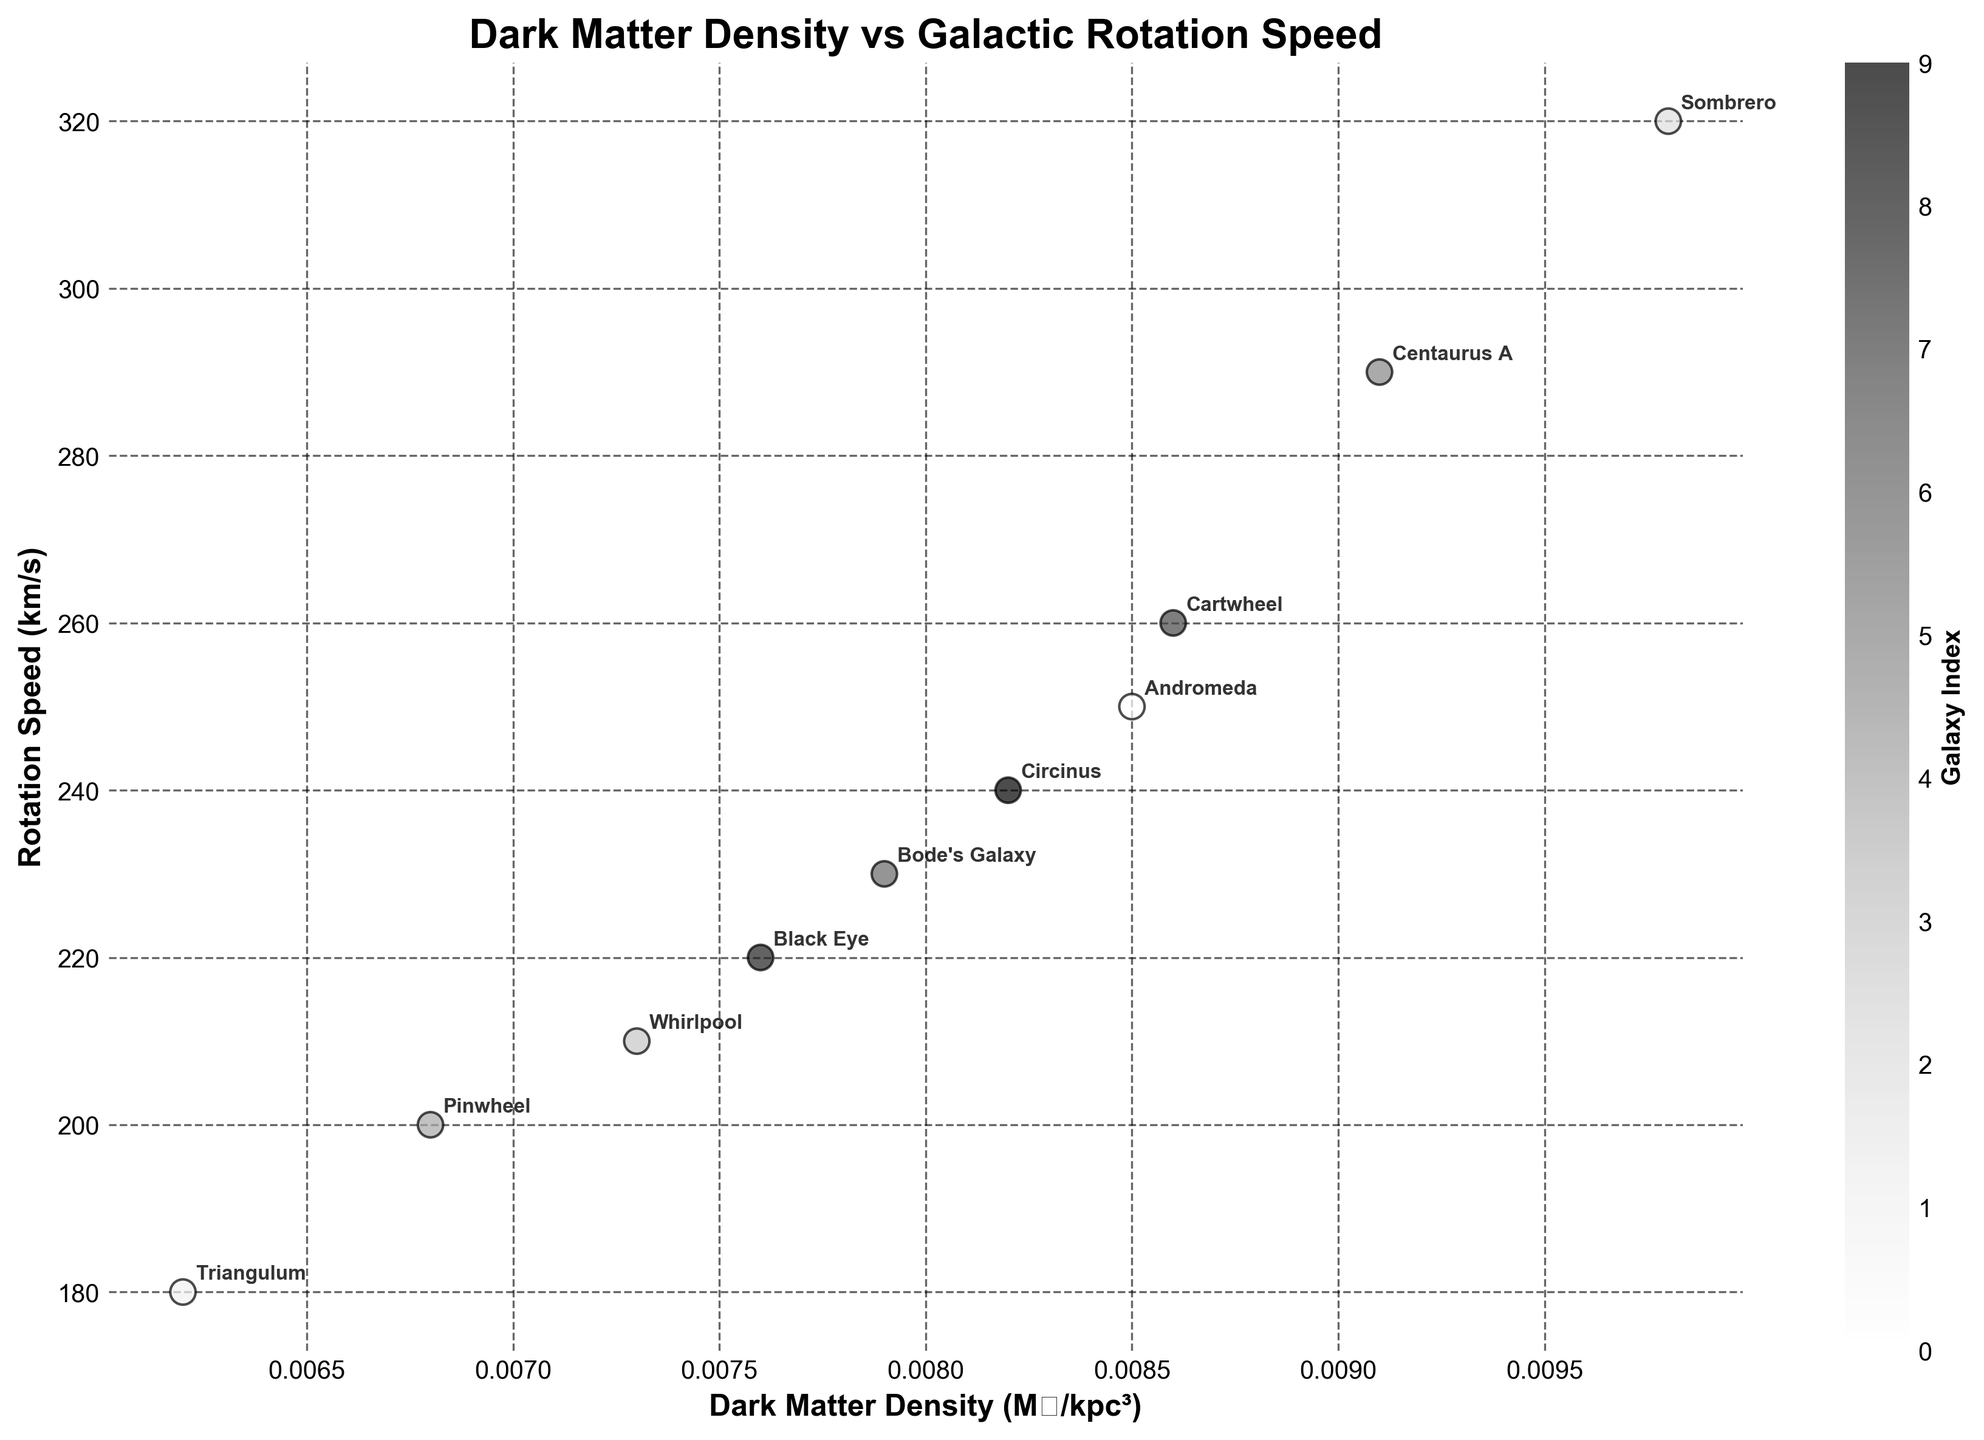what is the title of the plot? The title of the plot, which helps to understand what the visual representation is about, is located at the top center of the figure.
Answer: Dark Matter Density vs Galactic Rotation Speed How many galaxies are represented in the plot? By counting the number of data points, and noting each point's annotated label which represents a galaxy, one can determine the total number of galaxies.
Answer: 10 Which galaxy has the highest rotation speed? By looking at the scatter plot and identifying the point that corresponds to the highest y-axis value (Rotation Speed), you can find the galaxy with the highest rotation speed.
Answer: Sombrero What's the average dark matter density of all galaxies? First, sum the dark matter densities of all galaxies: (0.0085 + 0.0062 + 0.0098 + 0.0073 + 0.0068 + 0.0091 + 0.0079 + 0.0086 + 0.0076 + 0.0082) = 0.079. Then, divide this sum by the number of galaxies (10).
Answer: 0.0079 M☉/kpc³ Does a higher dark matter density correlate with a higher rotation speed? By observing the scatter plot trend, if points with higher x-values (representing dark matter density) also correspond to higher y-values (rotation speed), you determine if there's a positive correlation.
Answer: Yes, generally Which galaxy has the lowest dark matter density? By identifying the point with the minimum x-axis value on the scatter plot, you can find the galaxy with the lowest dark matter density.
Answer: Triangulum Which galaxies have both dark matter density and rotation speed above 0.008 M☉/kpc³ and 250 km/s respectively? By examining the plot for points that lie to the right of the x=0.008 vertical line and above the y=250 horizontal line, you determine the galaxies that meet both criteria.
Answer: Sombrero and Cartwheel What is the average rotation speed of all galaxies? First, sum the rotation speeds of all galaxies: (250 + 180 + 320 + 210 + 200 + 290 + 230 + 260 + 220 + 240) = 2400. Then, divide this sum by the number of galaxies (10).
Answer: 240 km/s Which galaxy has the closest dark matter density to 0.007 M☉/kpc³? By finding the point on the scatter plot closest to the x-axis value of 0.007, you determine the galaxy with a dark matter density closest to 0.007 M☉/kpc³.
Answer: Pinwheel 